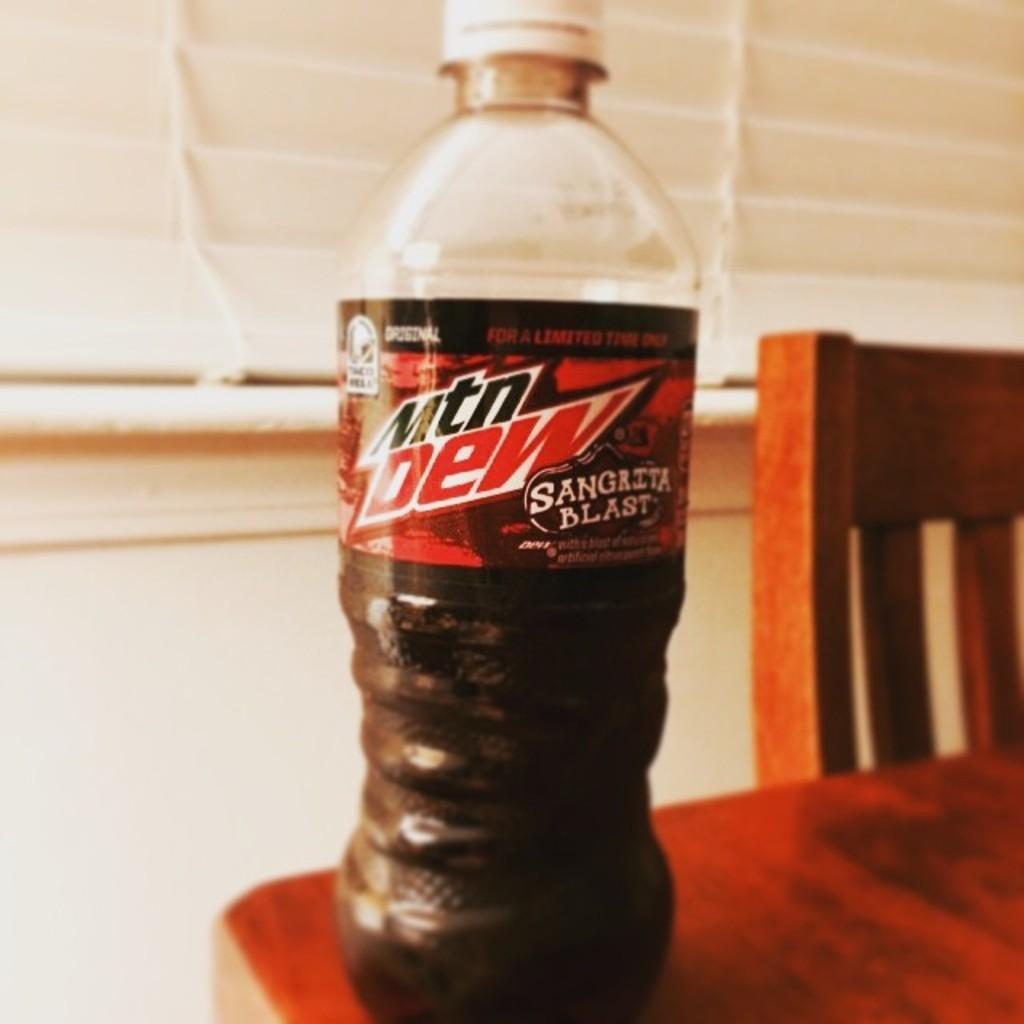Can you describe this image briefly? In the image we can see there is a juice bottle which is kept on table. 